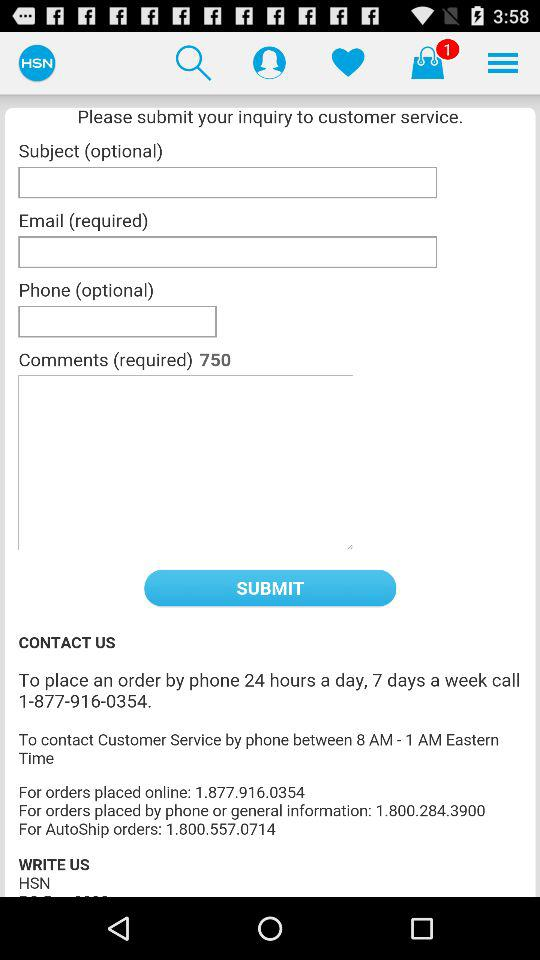What is the length of a comment? The length of a comment is 750. 